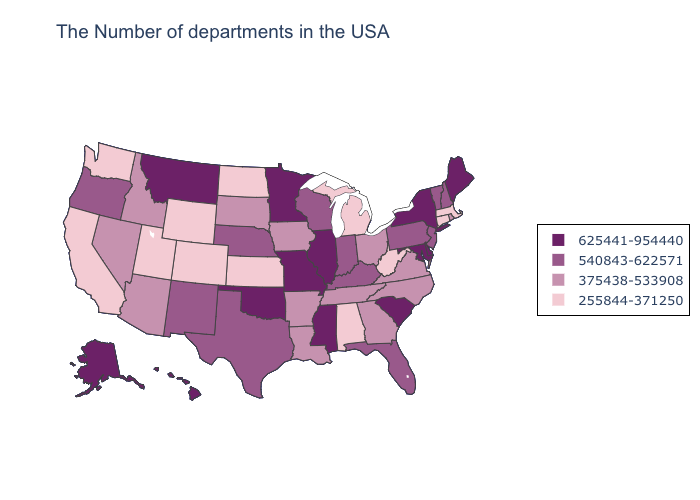Among the states that border California , which have the lowest value?
Give a very brief answer. Arizona, Nevada. What is the value of Maine?
Concise answer only. 625441-954440. Does Connecticut have the highest value in the Northeast?
Answer briefly. No. What is the highest value in the West ?
Keep it brief. 625441-954440. What is the value of Illinois?
Be succinct. 625441-954440. Does Ohio have the highest value in the USA?
Keep it brief. No. Name the states that have a value in the range 625441-954440?
Keep it brief. Maine, New York, Delaware, Maryland, South Carolina, Illinois, Mississippi, Missouri, Minnesota, Oklahoma, Montana, Alaska, Hawaii. Does Georgia have the same value as Montana?
Short answer required. No. Among the states that border Maryland , which have the lowest value?
Keep it brief. West Virginia. What is the value of New Mexico?
Short answer required. 540843-622571. What is the highest value in the USA?
Answer briefly. 625441-954440. Does New Mexico have the highest value in the West?
Concise answer only. No. Name the states that have a value in the range 540843-622571?
Short answer required. New Hampshire, Vermont, New Jersey, Pennsylvania, Florida, Kentucky, Indiana, Wisconsin, Nebraska, Texas, New Mexico, Oregon. What is the value of North Carolina?
Be succinct. 375438-533908. Name the states that have a value in the range 255844-371250?
Quick response, please. Massachusetts, Connecticut, West Virginia, Michigan, Alabama, Kansas, North Dakota, Wyoming, Colorado, Utah, California, Washington. 